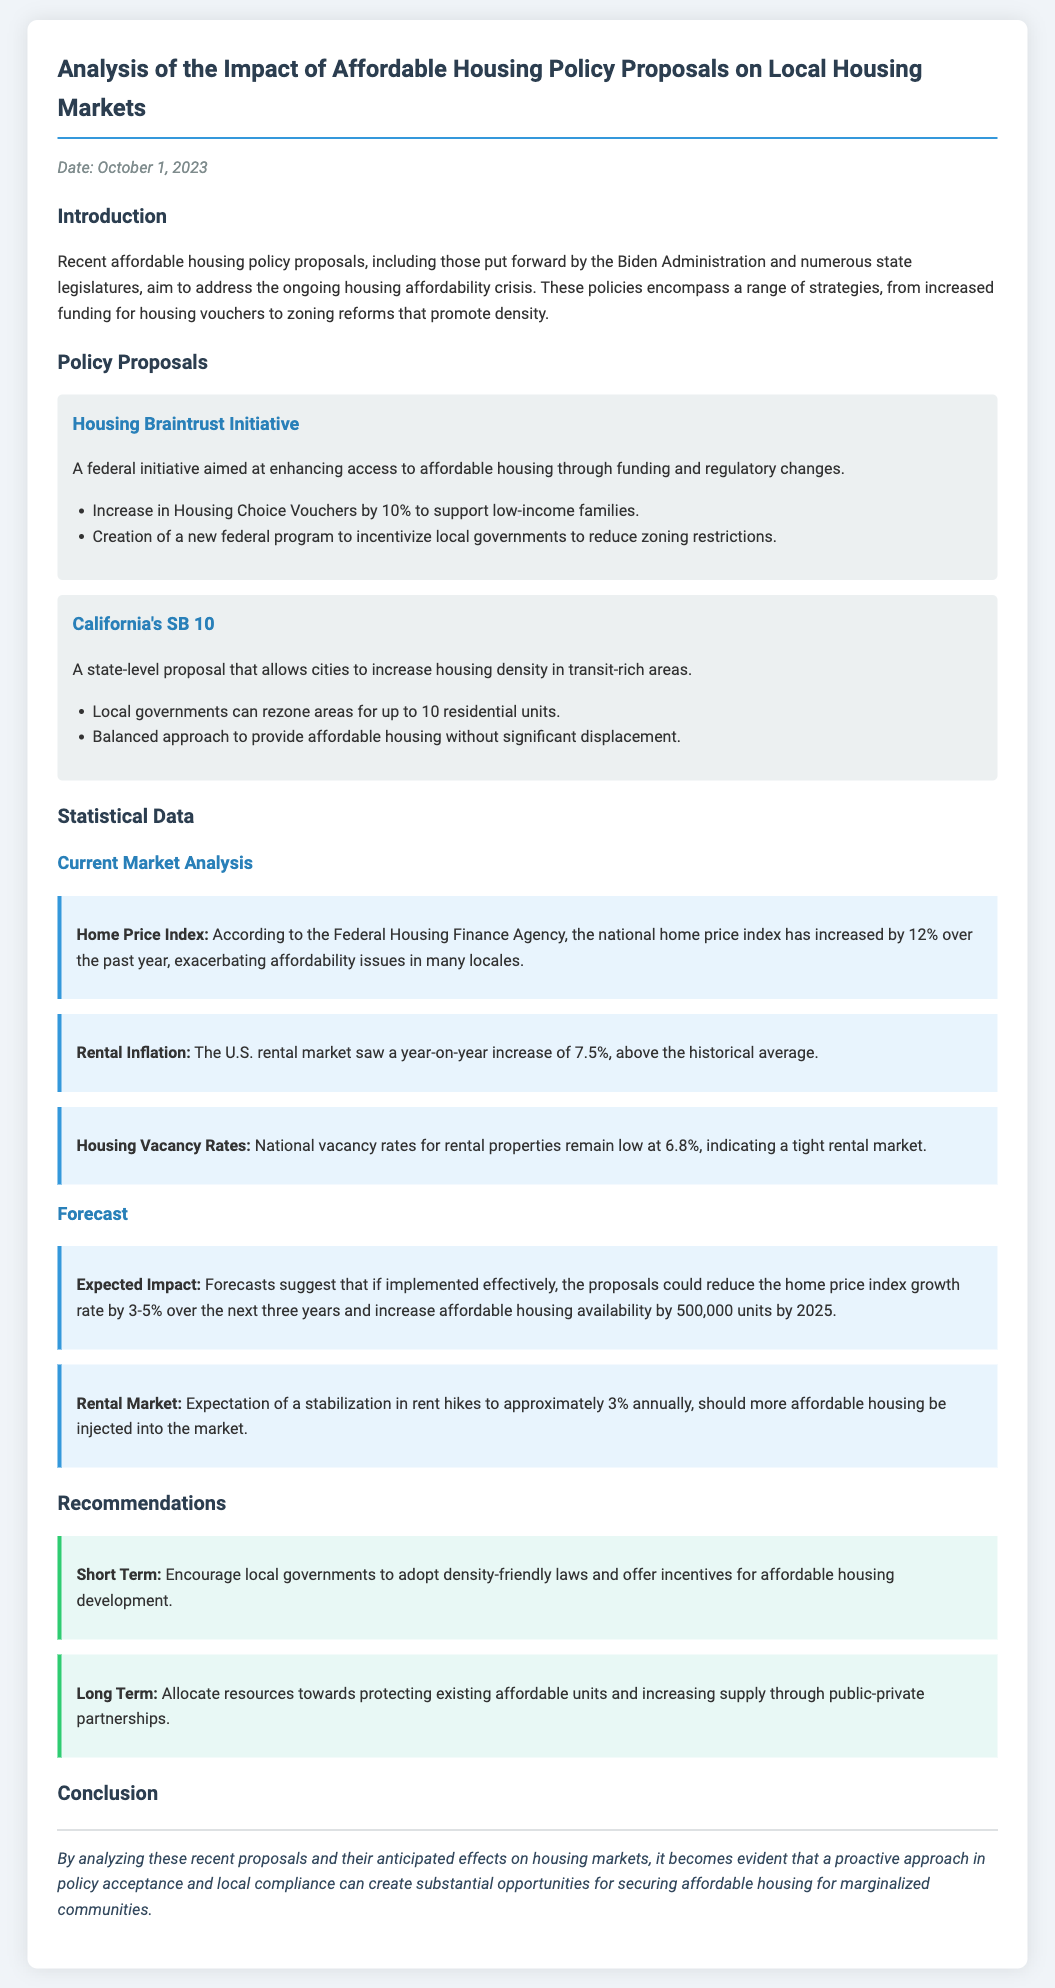What is the date of the memo? The date is clearly stated at the beginning of the memo.
Answer: October 1, 2023 What is the primary goal of the Housing Braintrust Initiative? The goal of the Housing Braintrust Initiative is specified in the description provided.
Answer: Enhancing access to affordable housing What percentage increase is proposed for Housing Choice Vouchers? The document specifies this percentage in the list of proposals under the Housing Braintrust Initiative.
Answer: 10% What was the year-on-year increase in home prices? This statistic is given in the current market analysis section of the document.
Answer: 12% What is the anticipated reduction in the home price index growth rate? This is mentioned in the forecasts section and provides an estimated range.
Answer: 3-5% What is the current national vacancy rate for rental properties? The document contains this specific data point in the current market analysis.
Answer: 6.8% What are the expected annual rent hikes if affordable housing is injected into the market? The forecast section of the memo provides this information.
Answer: Approximately 3% What is a short-term recommendation for local governments? The document outlines this recommendation in the recommendations section.
Answer: Density-friendly laws What is the expected increase in affordable housing availability by 2025? This forecast is stated in the forecasts section of the memo.
Answer: 500,000 units 